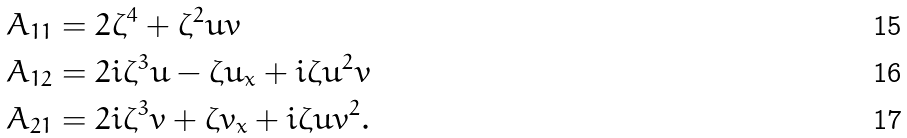<formula> <loc_0><loc_0><loc_500><loc_500>A _ { 1 1 } & = 2 \zeta ^ { 4 } + \zeta ^ { 2 } u v \\ A _ { 1 2 } & = 2 i \zeta ^ { 3 } u - \zeta u _ { x } + i \zeta u ^ { 2 } v \\ A _ { 2 1 } & = 2 i \zeta ^ { 3 } v + \zeta v _ { x } + i \zeta u v ^ { 2 } .</formula> 